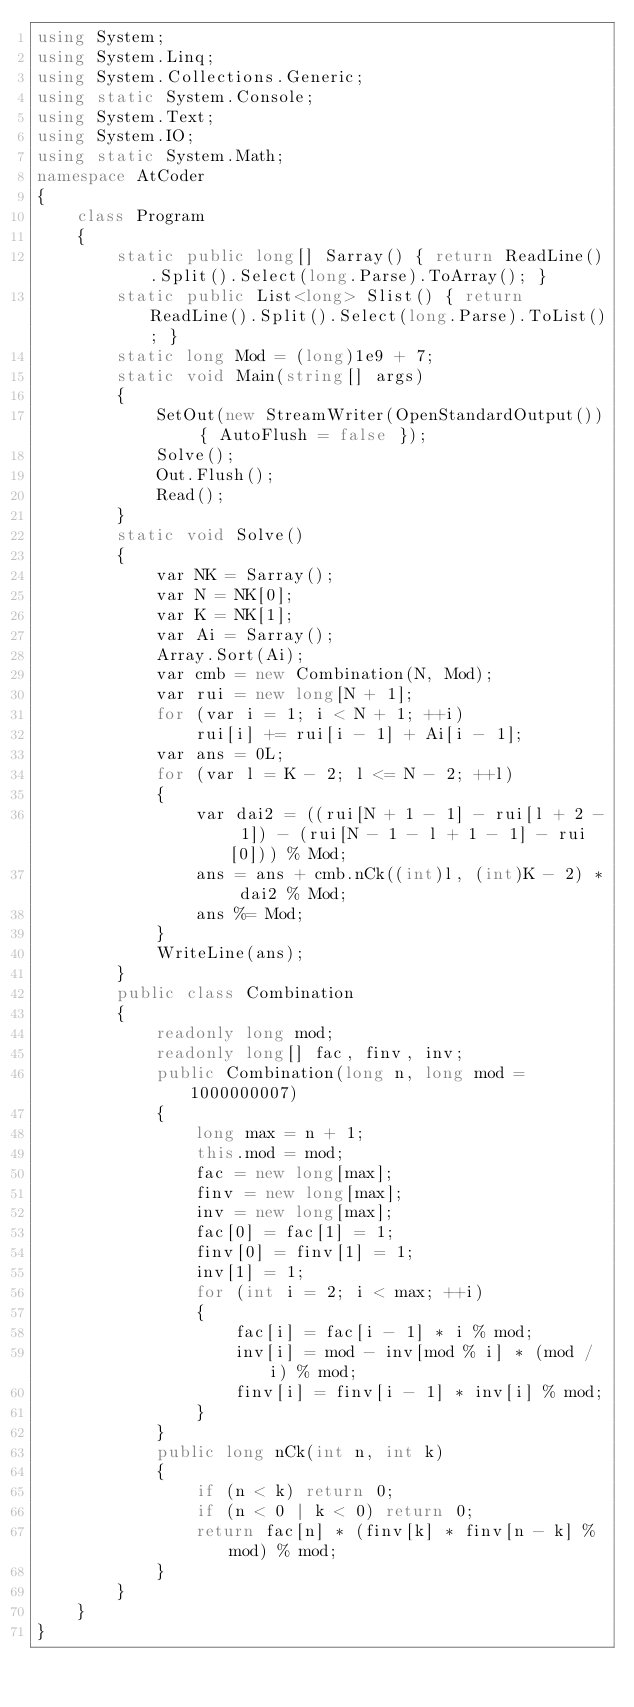Convert code to text. <code><loc_0><loc_0><loc_500><loc_500><_C#_>using System;
using System.Linq;
using System.Collections.Generic;
using static System.Console;
using System.Text;
using System.IO;
using static System.Math;
namespace AtCoder
{
    class Program
    {
        static public long[] Sarray() { return ReadLine().Split().Select(long.Parse).ToArray(); }
        static public List<long> Slist() { return ReadLine().Split().Select(long.Parse).ToList(); }
        static long Mod = (long)1e9 + 7;
        static void Main(string[] args)
        {
            SetOut(new StreamWriter(OpenStandardOutput()) { AutoFlush = false });
            Solve();
            Out.Flush();
            Read();
        }
        static void Solve()
        {
            var NK = Sarray();
            var N = NK[0];
            var K = NK[1];
            var Ai = Sarray();
            Array.Sort(Ai);
            var cmb = new Combination(N, Mod);
            var rui = new long[N + 1];
            for (var i = 1; i < N + 1; ++i)
                rui[i] += rui[i - 1] + Ai[i - 1];
            var ans = 0L;
            for (var l = K - 2; l <= N - 2; ++l)
            {
                var dai2 = ((rui[N + 1 - 1] - rui[l + 2 - 1]) - (rui[N - 1 - l + 1 - 1] - rui[0])) % Mod;
                ans = ans + cmb.nCk((int)l, (int)K - 2) * dai2 % Mod;
                ans %= Mod;
            }
            WriteLine(ans);
        }
        public class Combination
        {
            readonly long mod;
            readonly long[] fac, finv, inv;
            public Combination(long n, long mod = 1000000007)
            {
                long max = n + 1;
                this.mod = mod;
                fac = new long[max];
                finv = new long[max];
                inv = new long[max];
                fac[0] = fac[1] = 1;
                finv[0] = finv[1] = 1;
                inv[1] = 1;
                for (int i = 2; i < max; ++i)
                {
                    fac[i] = fac[i - 1] * i % mod;
                    inv[i] = mod - inv[mod % i] * (mod / i) % mod;
                    finv[i] = finv[i - 1] * inv[i] % mod;
                }
            }
            public long nCk(int n, int k)
            {
                if (n < k) return 0;
                if (n < 0 | k < 0) return 0;
                return fac[n] * (finv[k] * finv[n - k] % mod) % mod;
            }
        }
    }
}</code> 